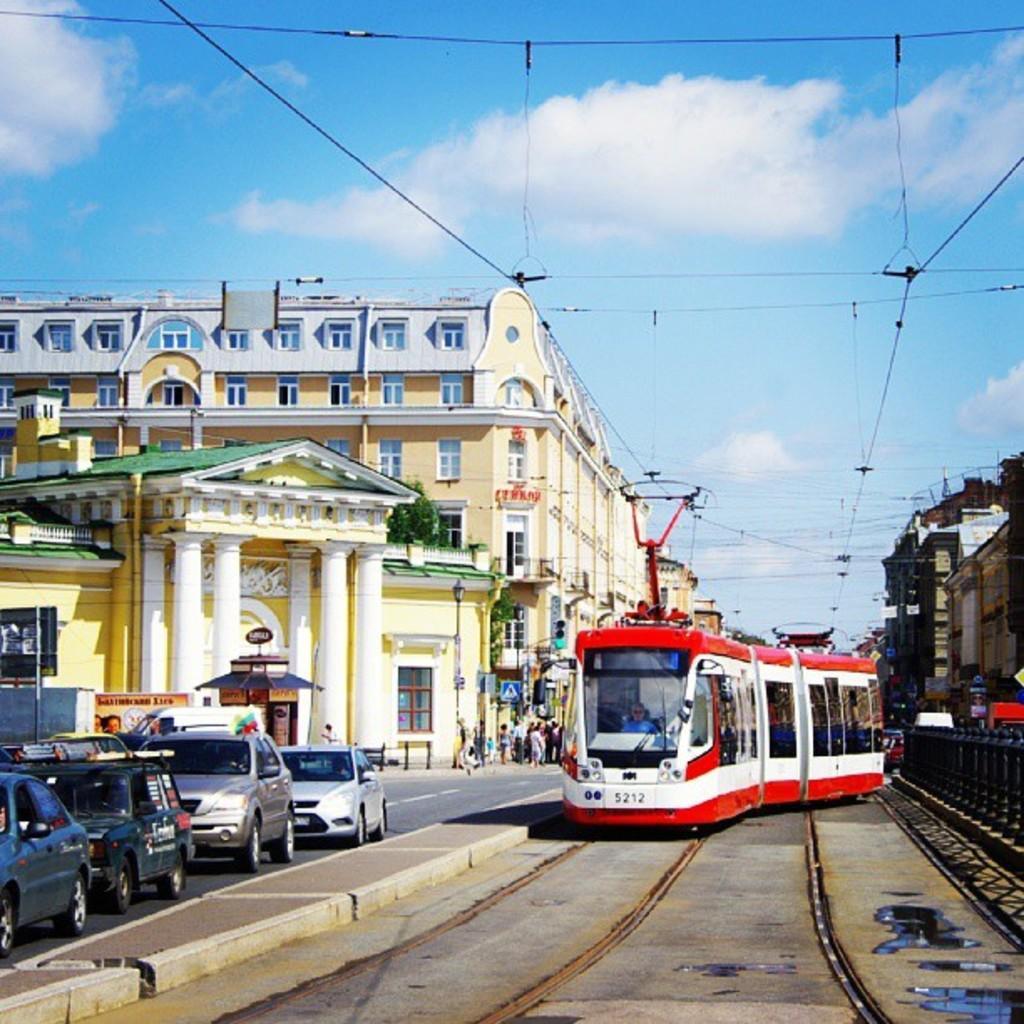Can you describe this image briefly? In this image, in the middle, we can see a train moving on the railway track, in the train, we can see a man riding it. On the right side, we can see a building, trees. on the left side, we can see some cars moving on the road, buildings, pillars, a group of people, windows. in the background, we can see some electrical wires. At the top, we can see a sky, at the bottom, we can see a railway track and a road. 